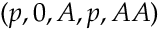<formula> <loc_0><loc_0><loc_500><loc_500>( p , 0 , A , p , A A )</formula> 